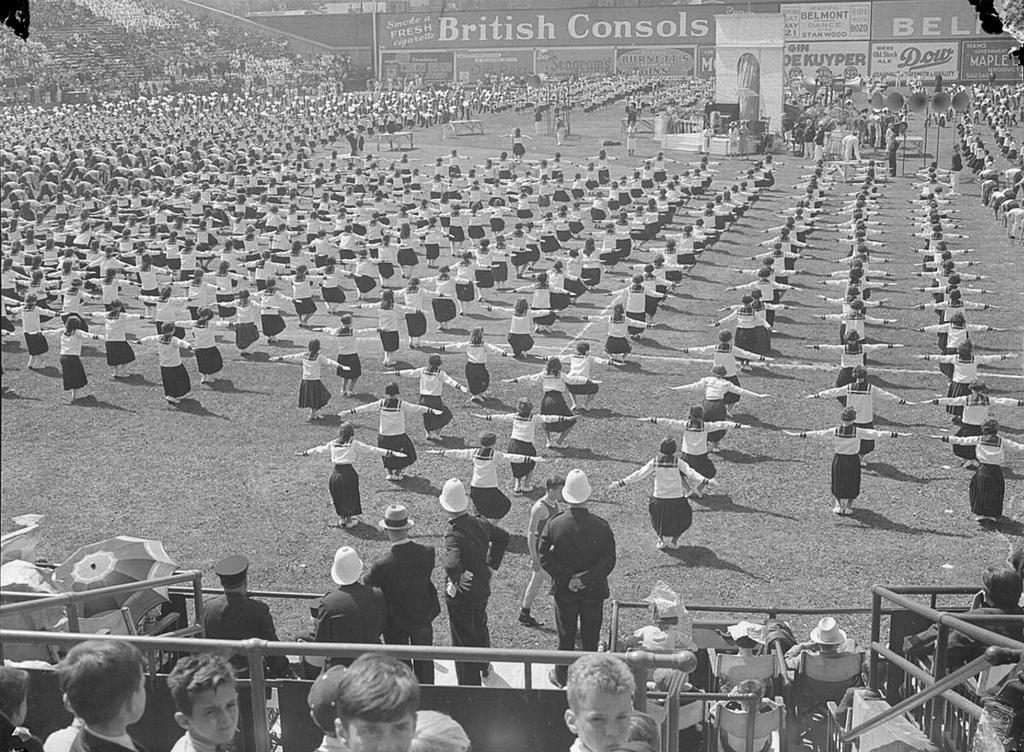Could you give a brief overview of what you see in this image? This is a black and white picture. Here we can see crowd and there are boards. 